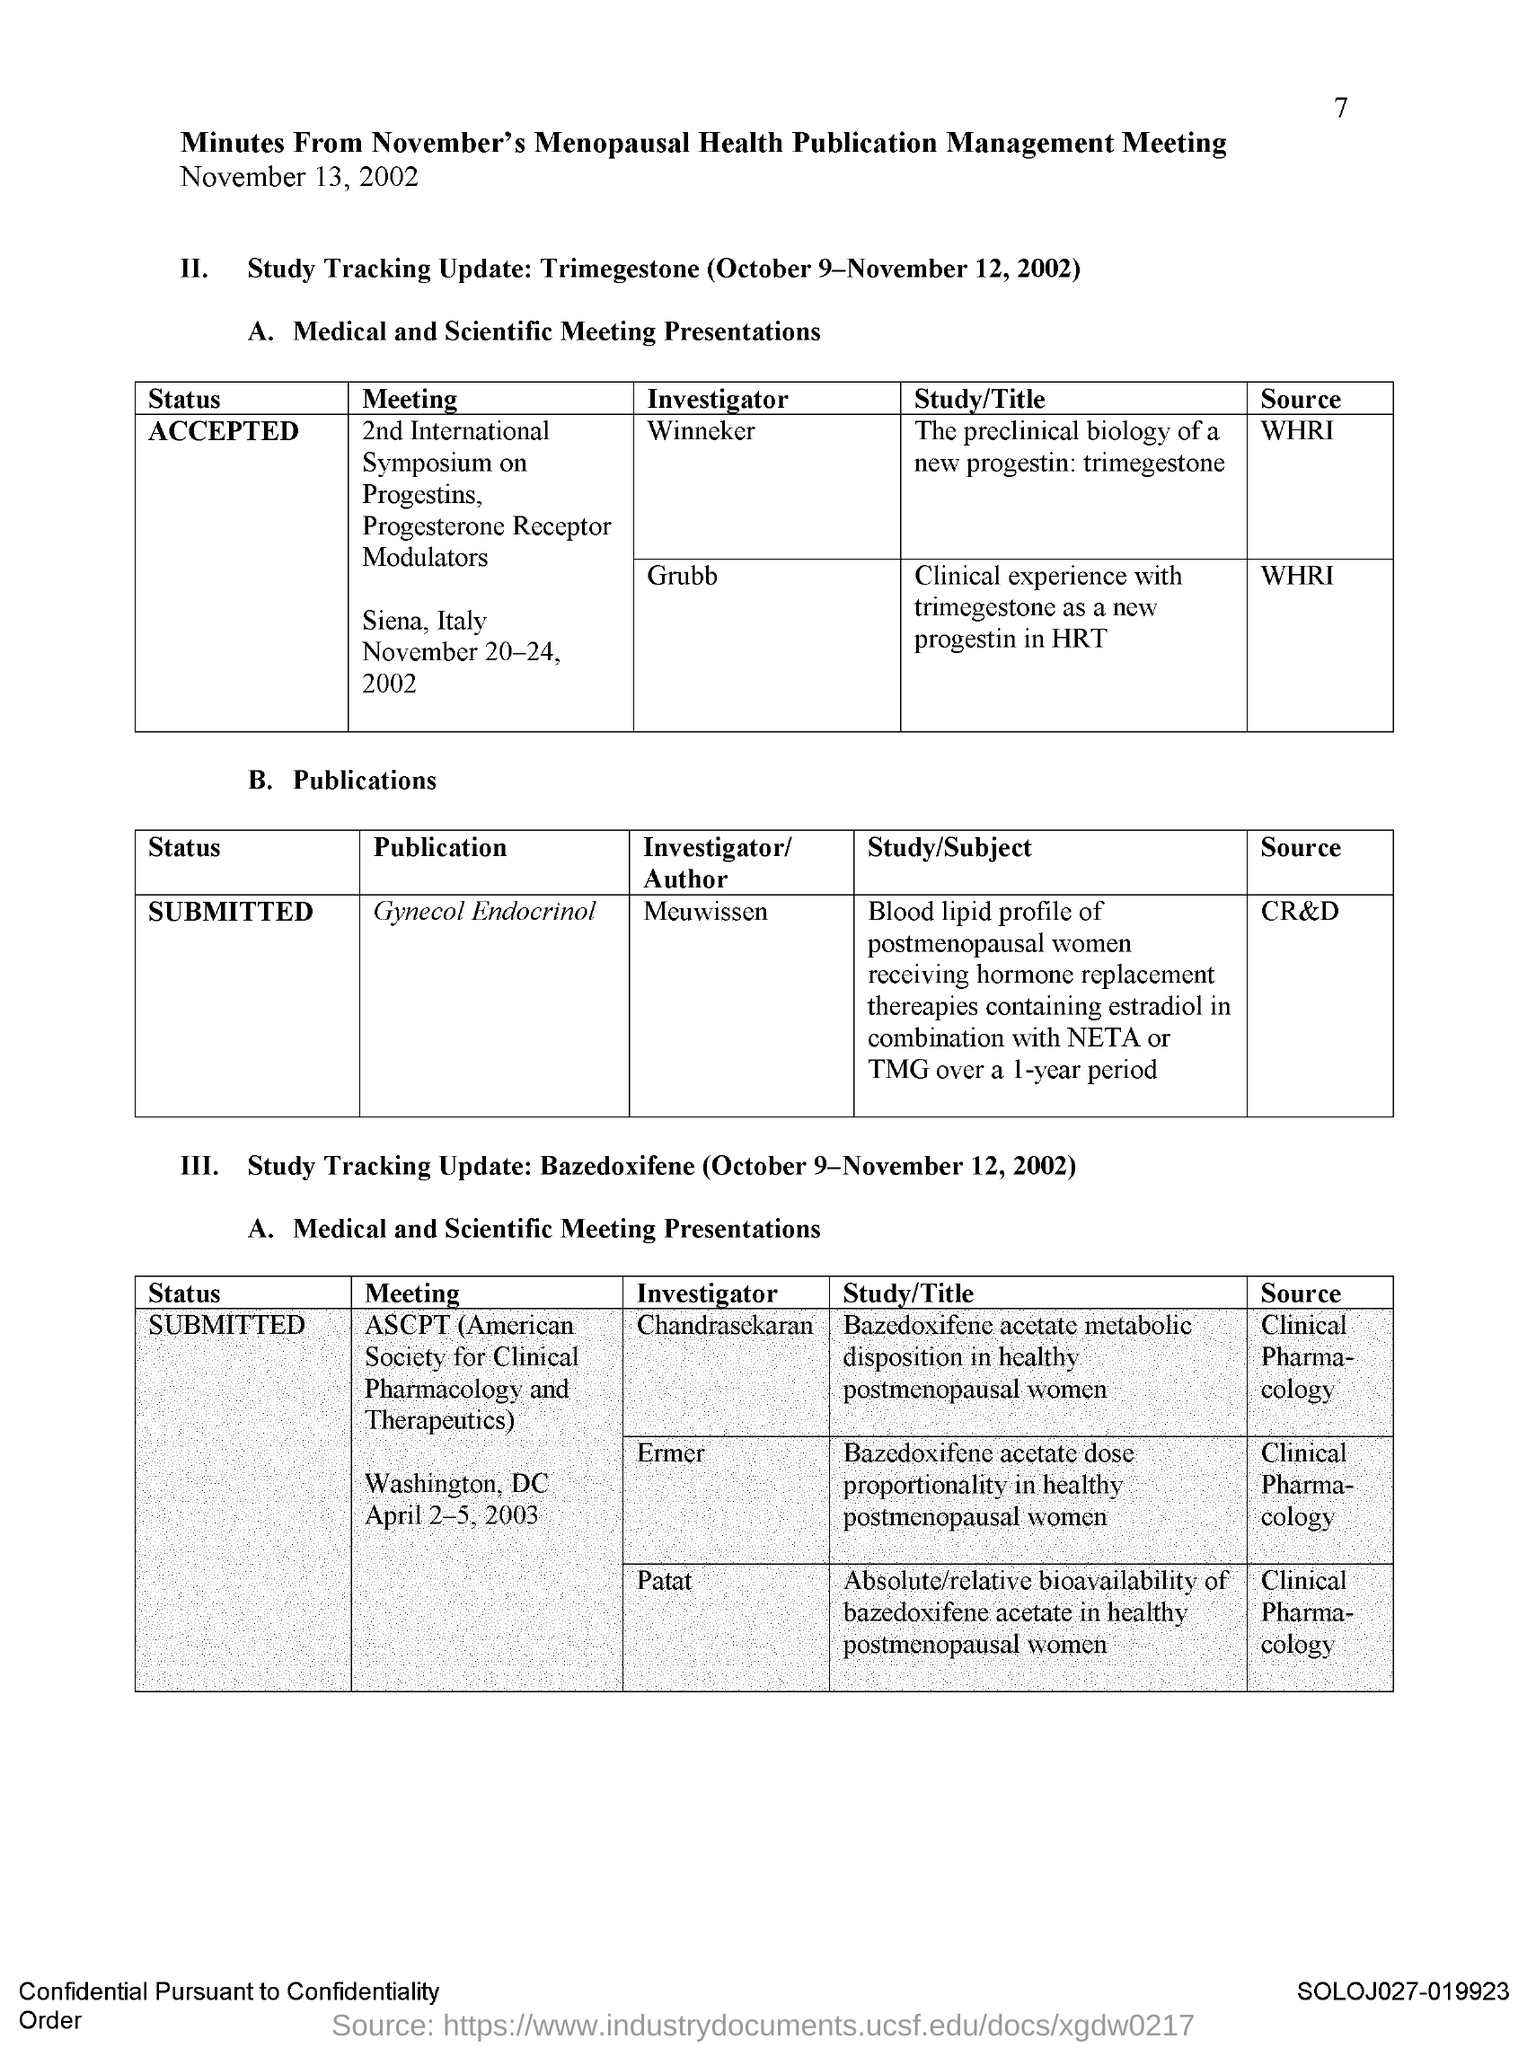Specify some key components in this picture. Meuwissen is the investigator of gynecology and endocrinology. 